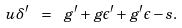<formula> <loc_0><loc_0><loc_500><loc_500>u \delta ^ { \prime } \ = \ g ^ { \prime } + g \epsilon ^ { \prime } + g ^ { \prime } \epsilon - s .</formula> 